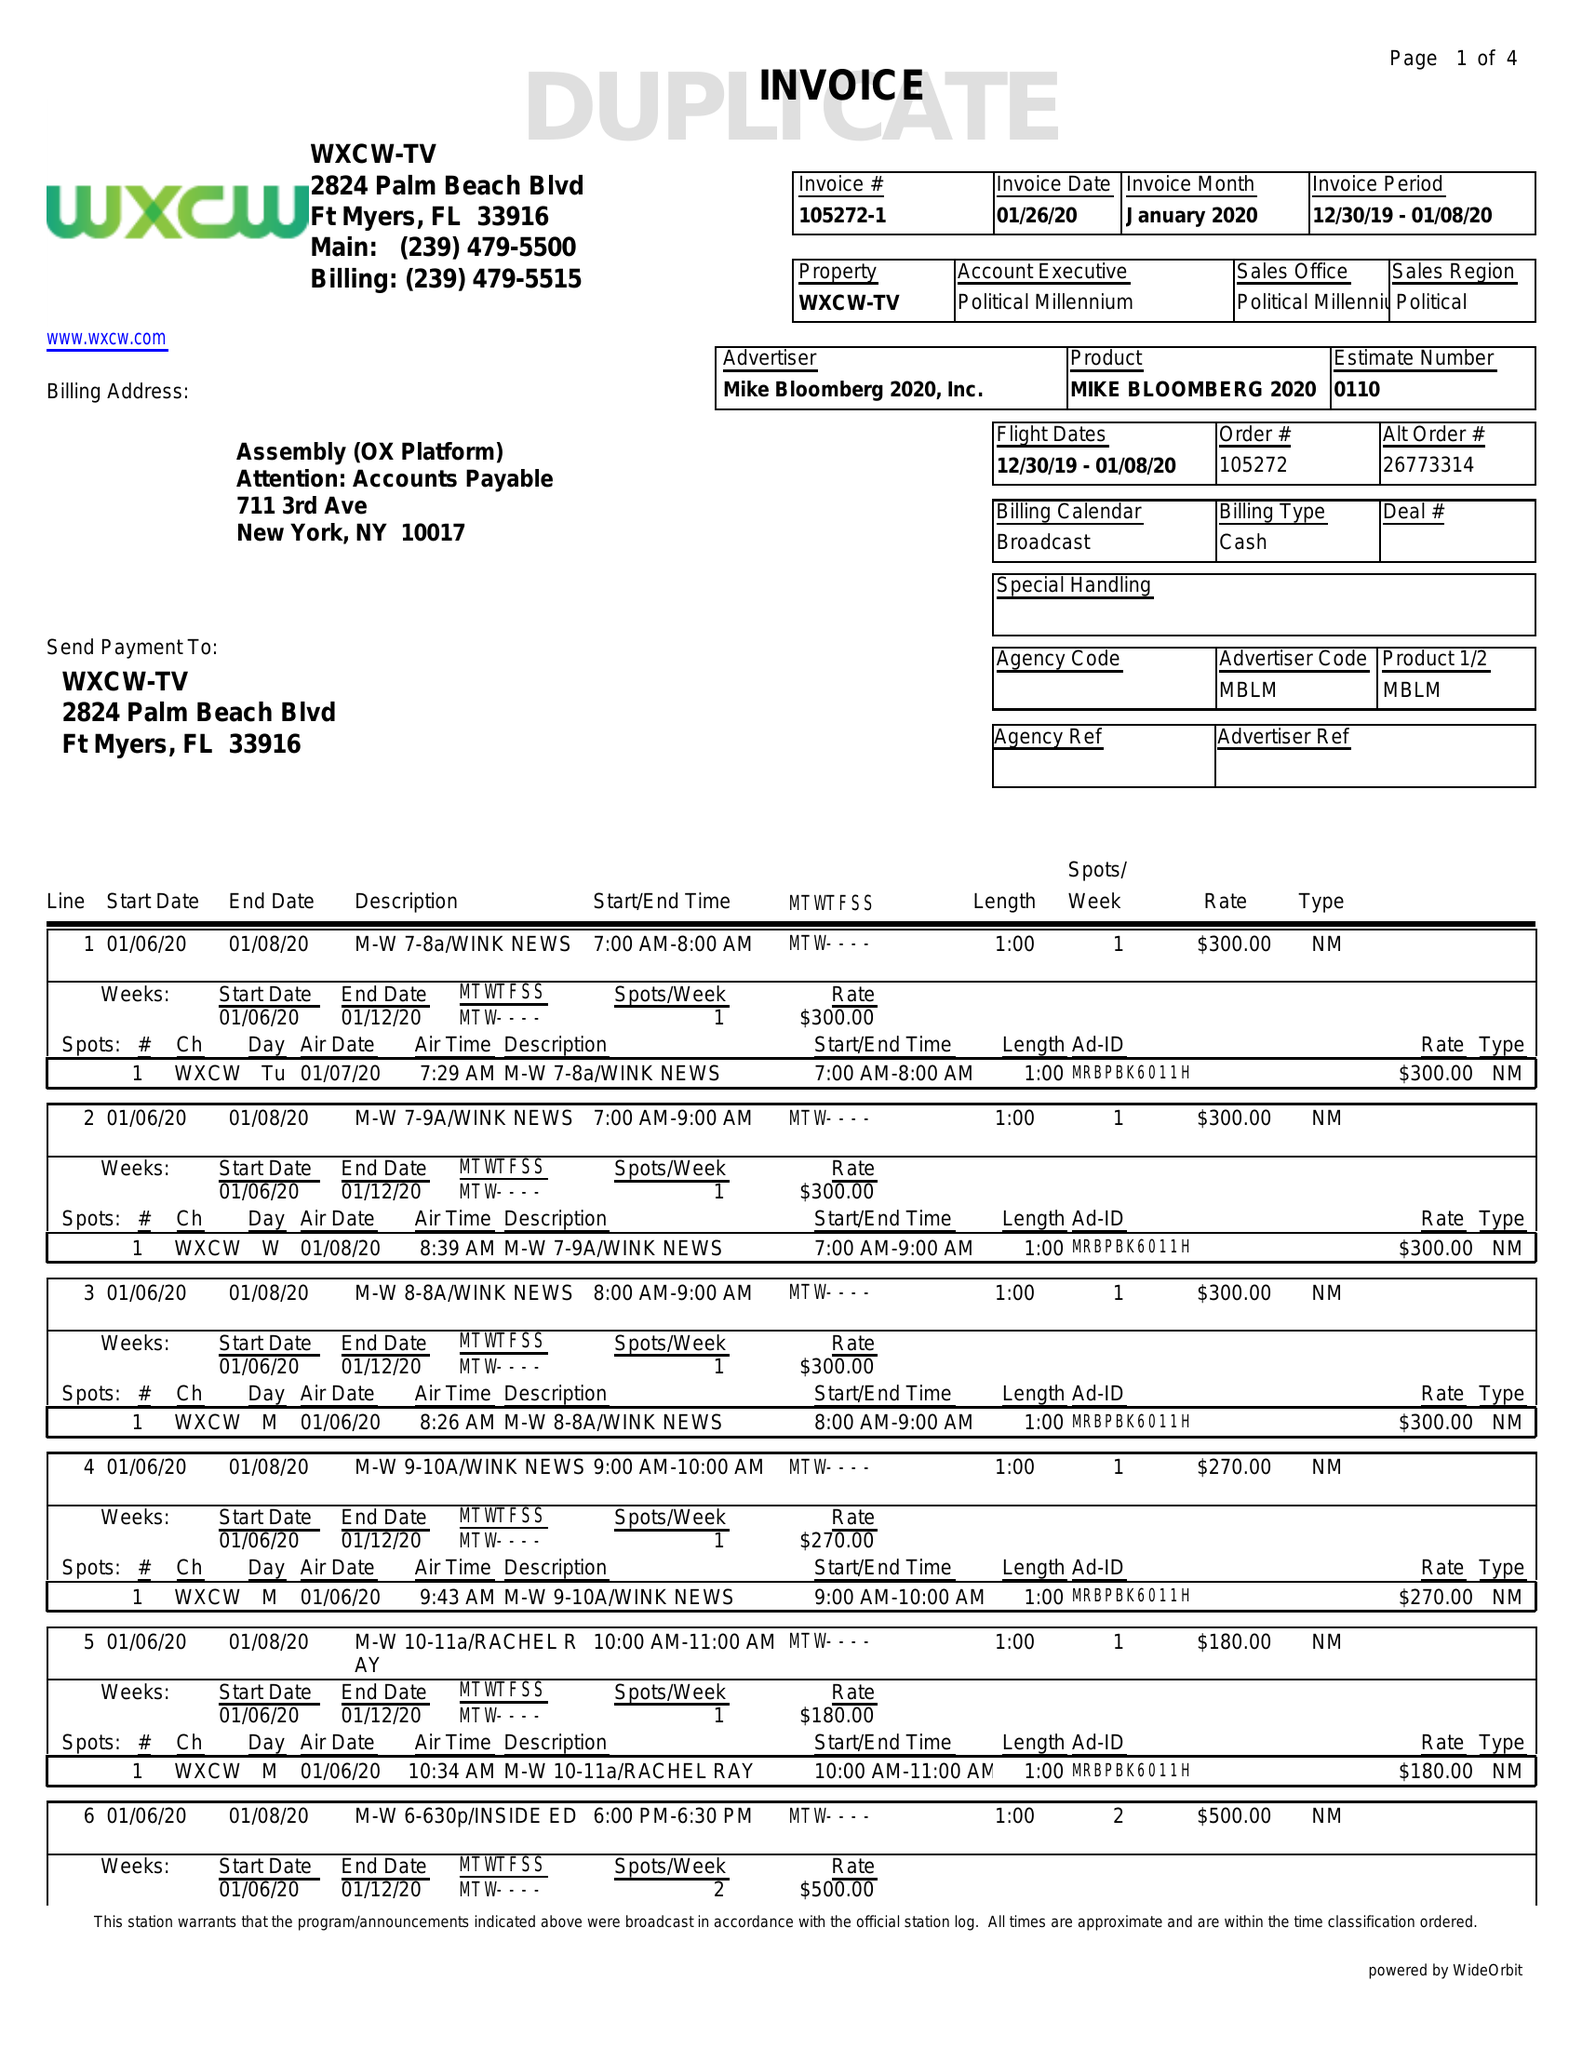What is the value for the advertiser?
Answer the question using a single word or phrase. MIKE BLOOMBERG 2020, INC. 